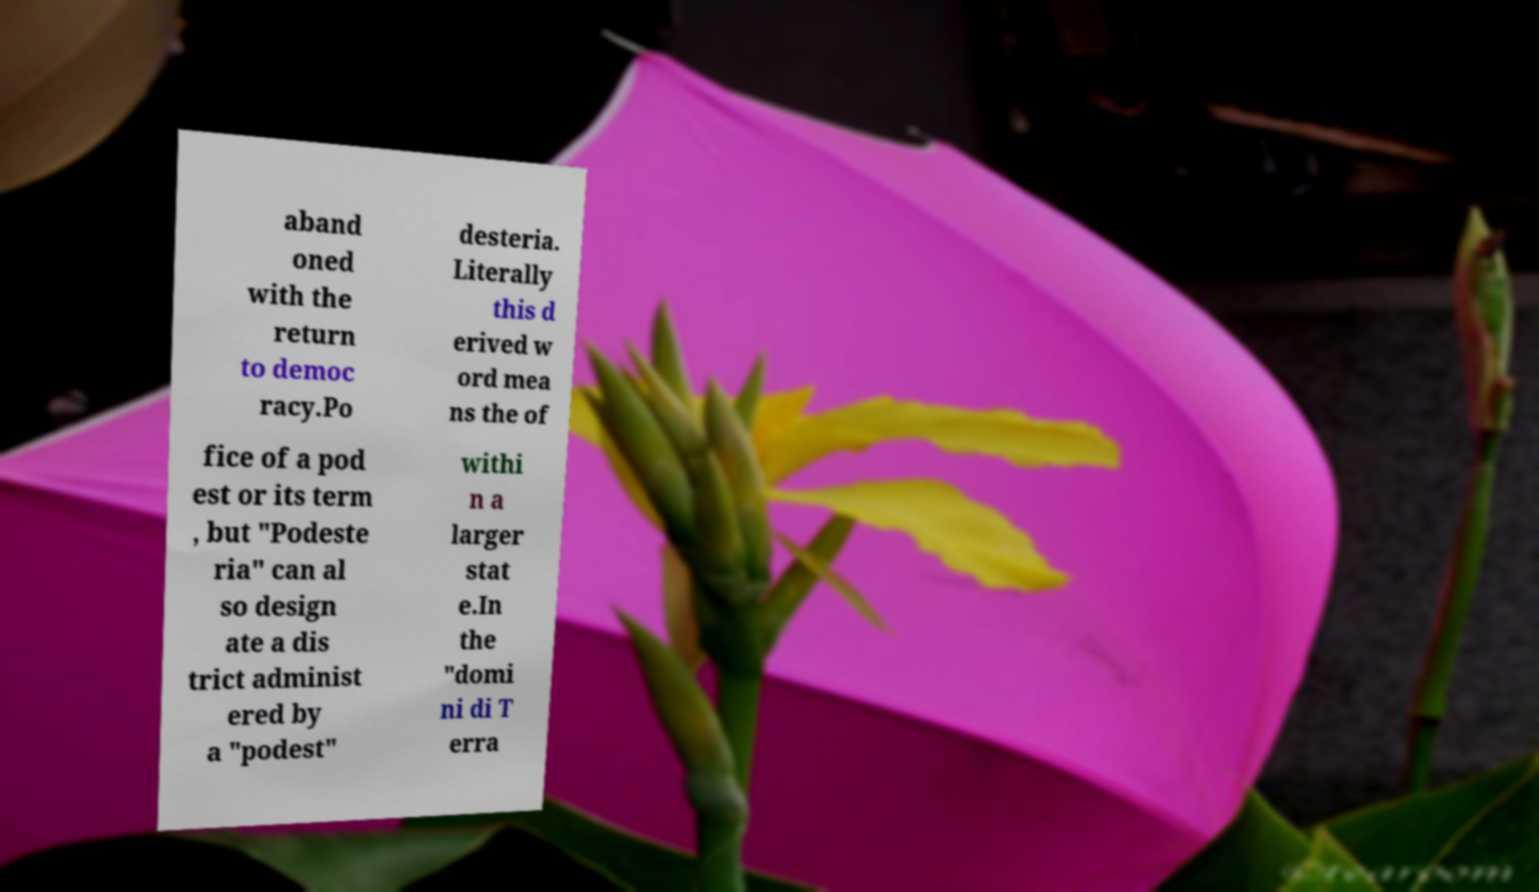What messages or text are displayed in this image? I need them in a readable, typed format. aband oned with the return to democ racy.Po desteria. Literally this d erived w ord mea ns the of fice of a pod est or its term , but "Podeste ria" can al so design ate a dis trict administ ered by a "podest" withi n a larger stat e.In the "domi ni di T erra 